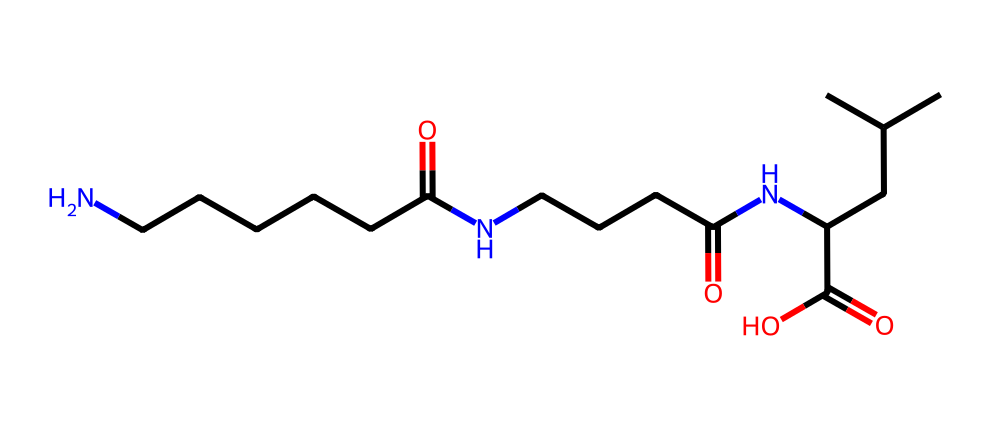What type of polymer is represented by the given SMILES? The structure shows amide functional groups (-C(=O)N-), which is characteristic of polyamides; thus, it is indicative of nylon.
Answer: nylon How many nitrogen atoms are present in the structure? By analyzing the SMILES, we can count the nitrogen atoms appearing in the amide portions and side chains; there are three nitrogen atoms in total.
Answer: three What functional groups are visible in this chemical structure? The visible functional groups include carbonyl groups (C=O) and amine groups (N-H from the nitrogen), which form the basis for amide linkages typical in nylon.
Answer: amide, carbonyl How many carbon atoms are in the structure? By counting the carbon atoms indicated in the SMILES notation, we find a total of 15 carbon atoms present in the entire structure.
Answer: fifteen Which part of the structure contributes to its strength and durability? The numerous amide linkages (-C(=O)N-) throughout the chain provide intermolecular hydrogen bonding, significantly enhancing the material's strength and durability.
Answer: amide linkages What is the primary use of nylon in football jerseys? Nylon is primarily used for its lightweight and moisture-wicking properties, which help in keeping players dry and comfortable during matches.
Answer: moisture-wicking How does the polymerization process influence the characteristics of nylon in jerseys? The polymerization leads to the formation of long, repeating chains of nylon, resulting in high tensile strength and resistance to wear and tear, essential for athletic wear.
Answer: high tensile strength 